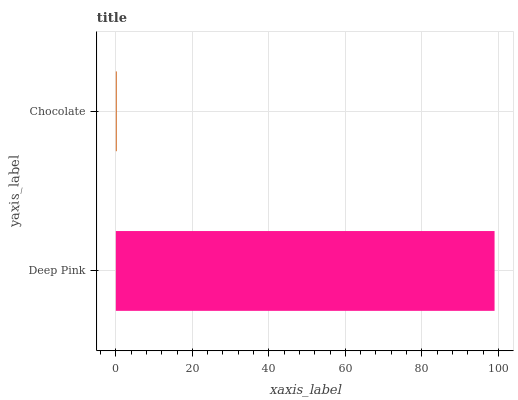Is Chocolate the minimum?
Answer yes or no. Yes. Is Deep Pink the maximum?
Answer yes or no. Yes. Is Chocolate the maximum?
Answer yes or no. No. Is Deep Pink greater than Chocolate?
Answer yes or no. Yes. Is Chocolate less than Deep Pink?
Answer yes or no. Yes. Is Chocolate greater than Deep Pink?
Answer yes or no. No. Is Deep Pink less than Chocolate?
Answer yes or no. No. Is Deep Pink the high median?
Answer yes or no. Yes. Is Chocolate the low median?
Answer yes or no. Yes. Is Chocolate the high median?
Answer yes or no. No. Is Deep Pink the low median?
Answer yes or no. No. 